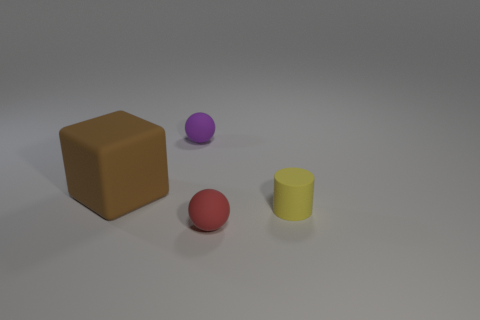Can you describe the color and relative size of the object that is to the left of the largest object? The object to the left of the largest object is a red sphere. Compared to the largest object, which is a brown cube, the red sphere is considerably smaller. 